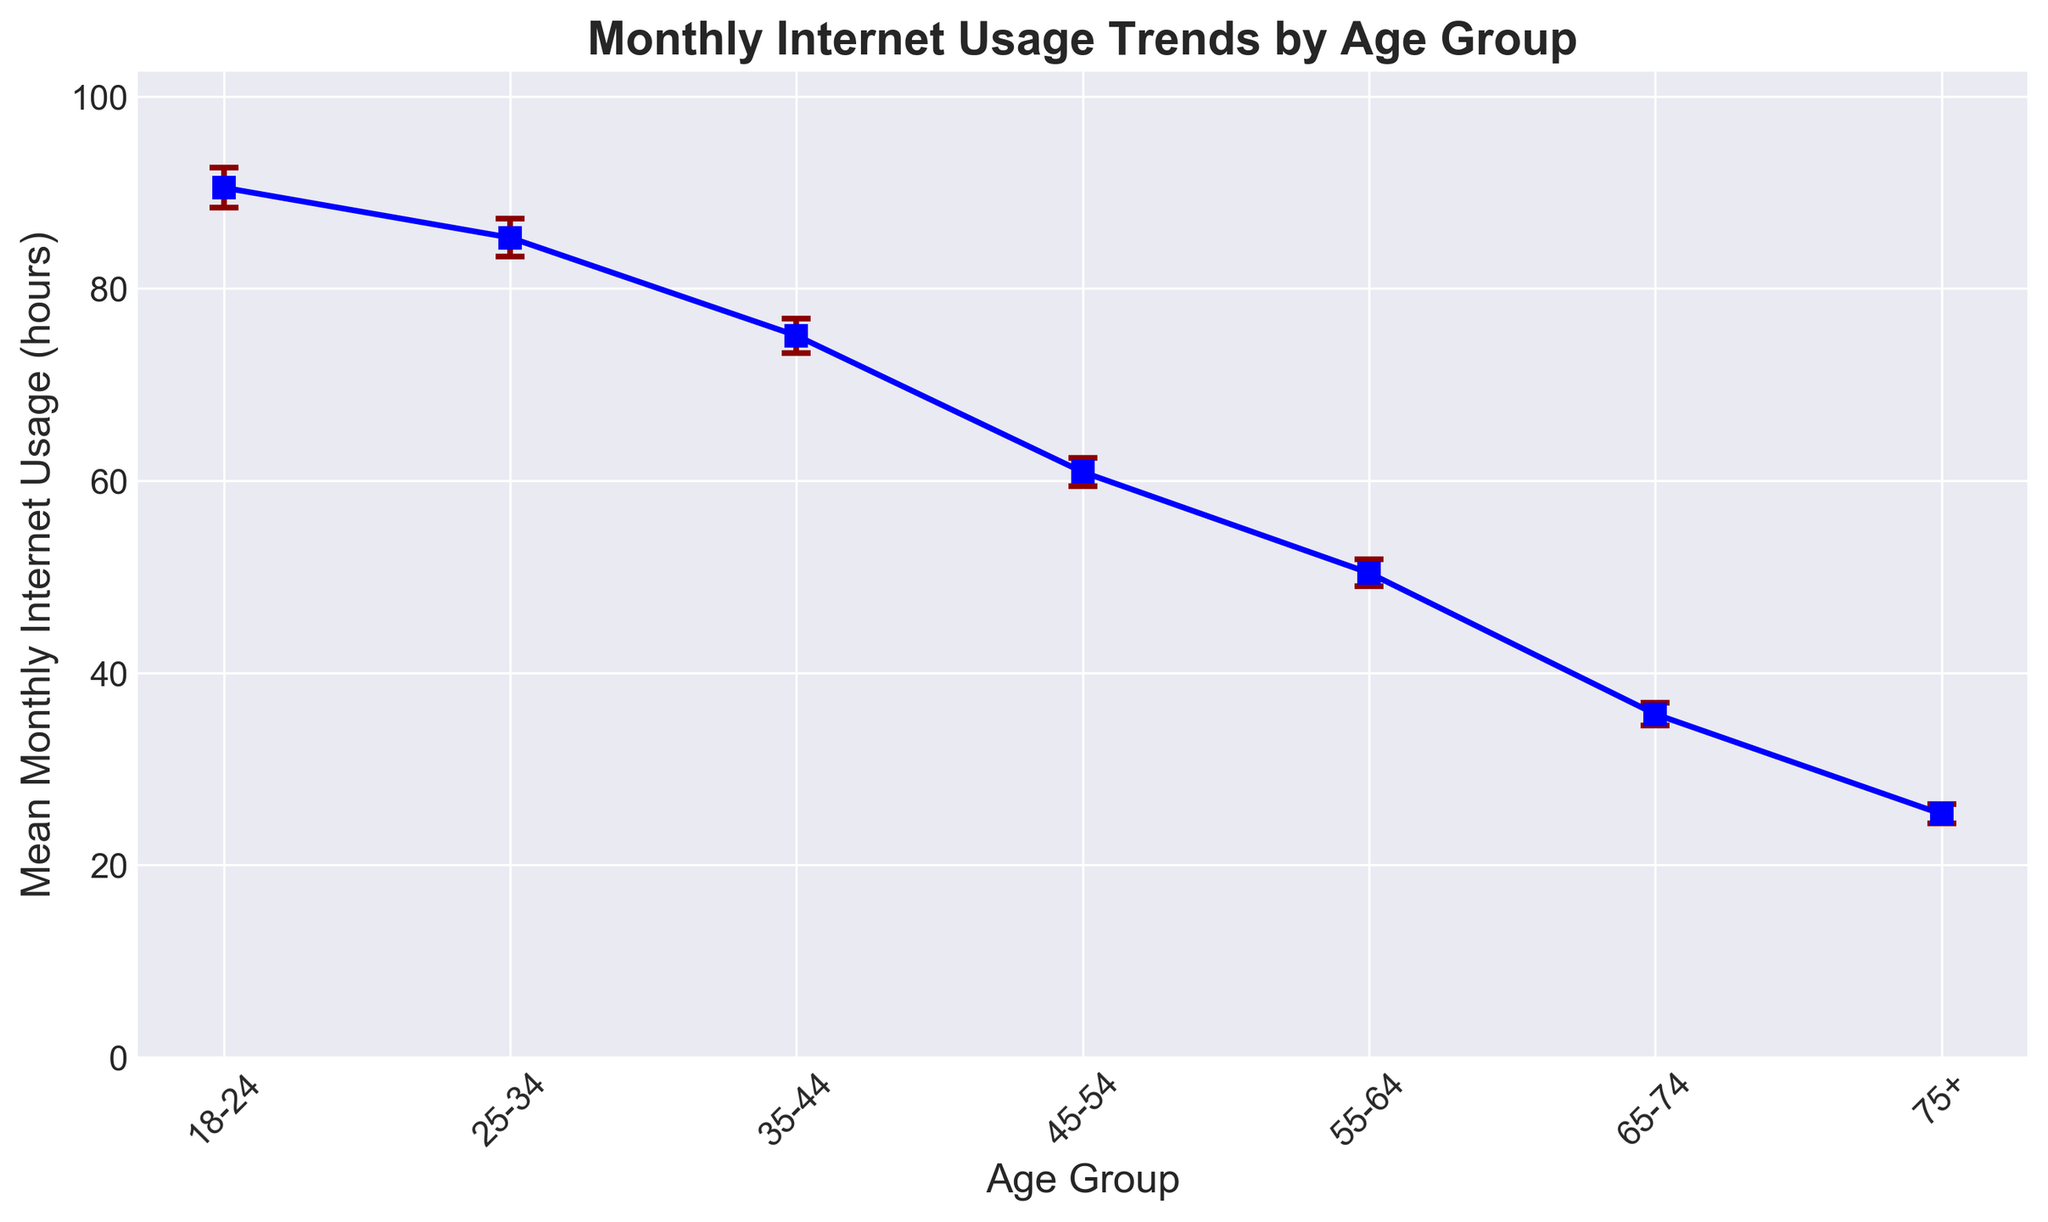Which age group has the highest mean monthly internet usage? By looking at the height of the points on the Y-axis, the 18-24 age group has the highest mean monthly internet usage.
Answer: 18-24 What is the mean monthly internet usage for the 25-34 age group, and how does it compare to the 55-64 age group? The mean for the 25-34 age group is 85.3 hours, and for the 55-64 age group is 50.4 hours. The 25-34 age group uses the internet 34.9 hours more than the 55-64 age group.
Answer: 85.3 hours; 34.9 hours more What is the difference in standard errors between the 35-44 and 75+ age groups? The standard error for 35-44 is 1.8 hours and for 75+ is 1.0 hours. The difference in standard errors is 1.8 - 1.0 = 0.8 hours.
Answer: 0.8 hours Which age group shows the lowest mean monthly internet usage and what is its standard error? The 75+ age group has the lowest mean monthly internet usage at 25.3 hours, with a standard error of 1.0 hours.
Answer: 75+; 1.0 hours What's the average of the mean monthly internet usage of the age groups from 18-24 to 45-54? First, sum up the means of the 18-24, 25-34, 35-44, and 45-54 age groups: 90.5 + 85.3 + 75.1 + 60.9 = 311.8. There are 4 groups, so the average is 311.8 / 4 = 77.95 hours.
Answer: 77.95 hours How much more is the mean monthly internet usage of the 18-24 age group compared to the 65-74 age group? The mean usage for the 18-24 age group is 90.5 hours, and for the 65-74 age group is 35.7 hours. The difference is 90.5 - 35.7 = 54.8 hours.
Answer: 54.8 hours Are the error bars for the 18-24 and 25-34 age groups the same length? Error bars represent the standard error. For 18-24, it's 2.1 hours, and for 25-34, it's 2.0 hours. Since 2.1 is slightly larger than 2.0, the error bars are not the same length.
Answer: No Does the 45-54 age group have a higher or lower mean monthly internet usage than the 35-44 age group? The 45-54 age group has a mean of 60.9 hours, while the 35-44 age group has a mean of 75.1 hours. Therefore, the 45-54 group uses the internet less.
Answer: Lower What is the range of mean monthly internet usage across all age groups? The highest mean monthly usage is 90.5 hours (18-24 group), and the lowest is 25.3 hours (75+ group). The range is 90.5 - 25.3 = 65.2 hours.
Answer: 65.2 hours 